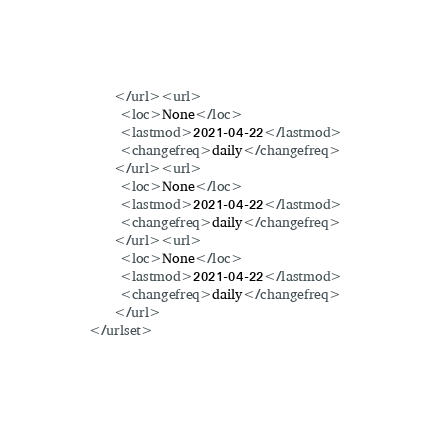<code> <loc_0><loc_0><loc_500><loc_500><_XML_>    </url><url>
     <loc>None</loc>
     <lastmod>2021-04-22</lastmod>
     <changefreq>daily</changefreq>
    </url><url>
     <loc>None</loc>
     <lastmod>2021-04-22</lastmod>
     <changefreq>daily</changefreq>
    </url><url>
     <loc>None</loc>
     <lastmod>2021-04-22</lastmod>
     <changefreq>daily</changefreq>
    </url>
</urlset></code> 